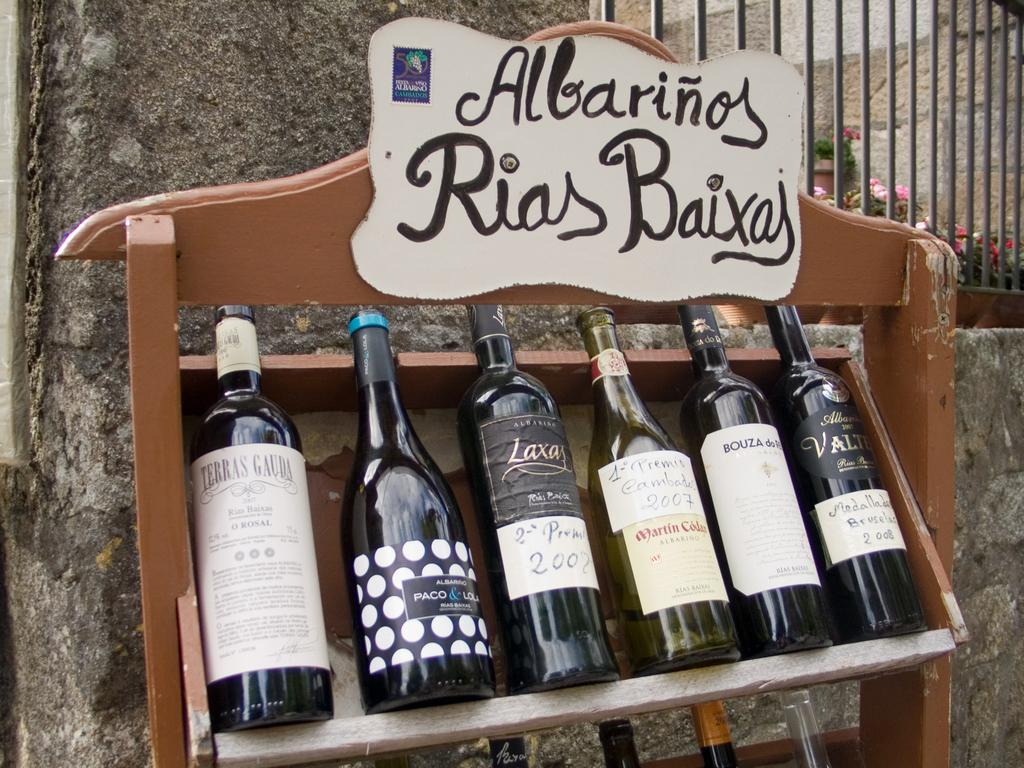Provide a one-sentence caption for the provided image. several bottles of wines displayed on a case reading Albarinos Rias Baixas. 